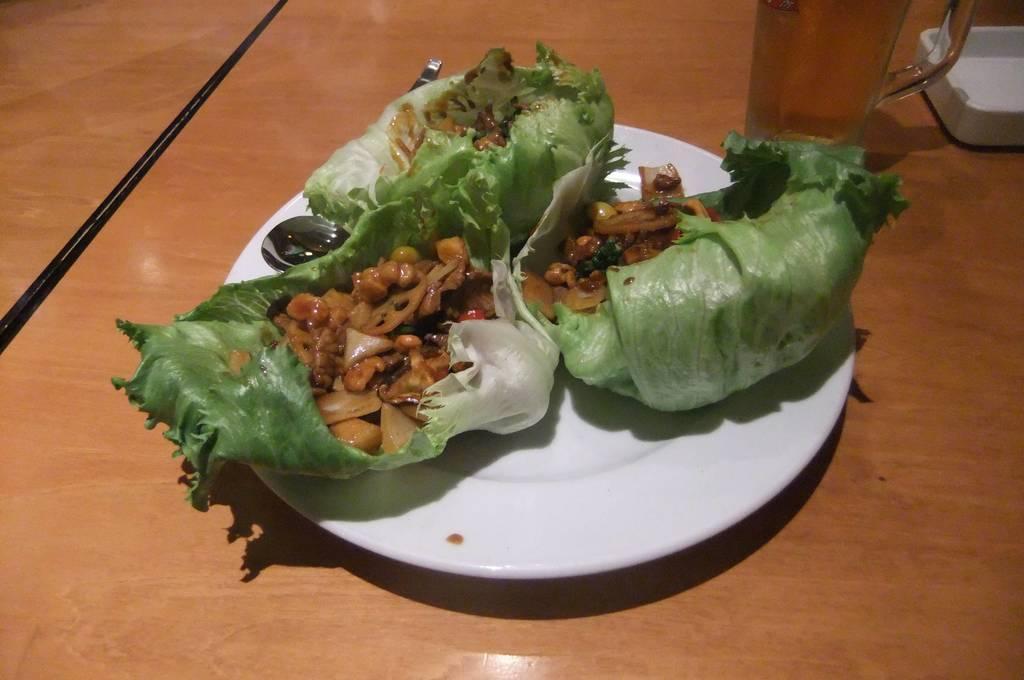In one or two sentences, can you explain what this image depicts? In this picture I can see food and a spoon in the plate and I can see a glass and it looks like a ashtray on the table. 